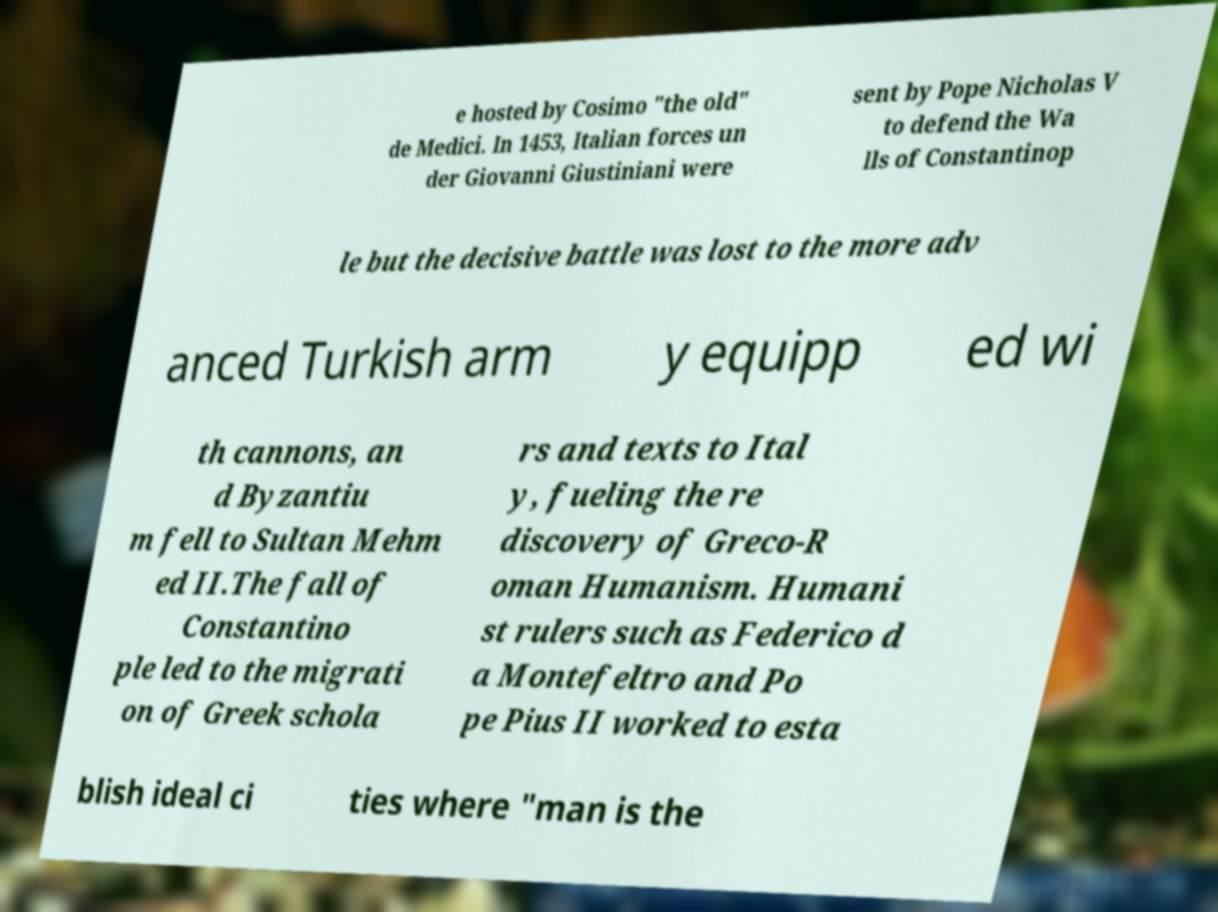Can you accurately transcribe the text from the provided image for me? e hosted by Cosimo "the old" de Medici. In 1453, Italian forces un der Giovanni Giustiniani were sent by Pope Nicholas V to defend the Wa lls of Constantinop le but the decisive battle was lost to the more adv anced Turkish arm y equipp ed wi th cannons, an d Byzantiu m fell to Sultan Mehm ed II.The fall of Constantino ple led to the migrati on of Greek schola rs and texts to Ital y, fueling the re discovery of Greco-R oman Humanism. Humani st rulers such as Federico d a Montefeltro and Po pe Pius II worked to esta blish ideal ci ties where "man is the 